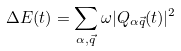Convert formula to latex. <formula><loc_0><loc_0><loc_500><loc_500>\Delta E ( t ) = \sum _ { \alpha , \vec { q } } \omega | Q _ { \alpha \vec { q } } ( t ) | ^ { 2 }</formula> 